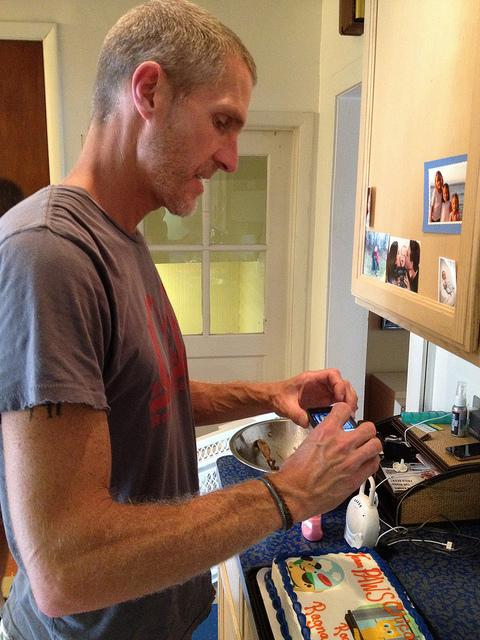What is the blue rectangular plastic item used to hold at the top of the desk? pills 